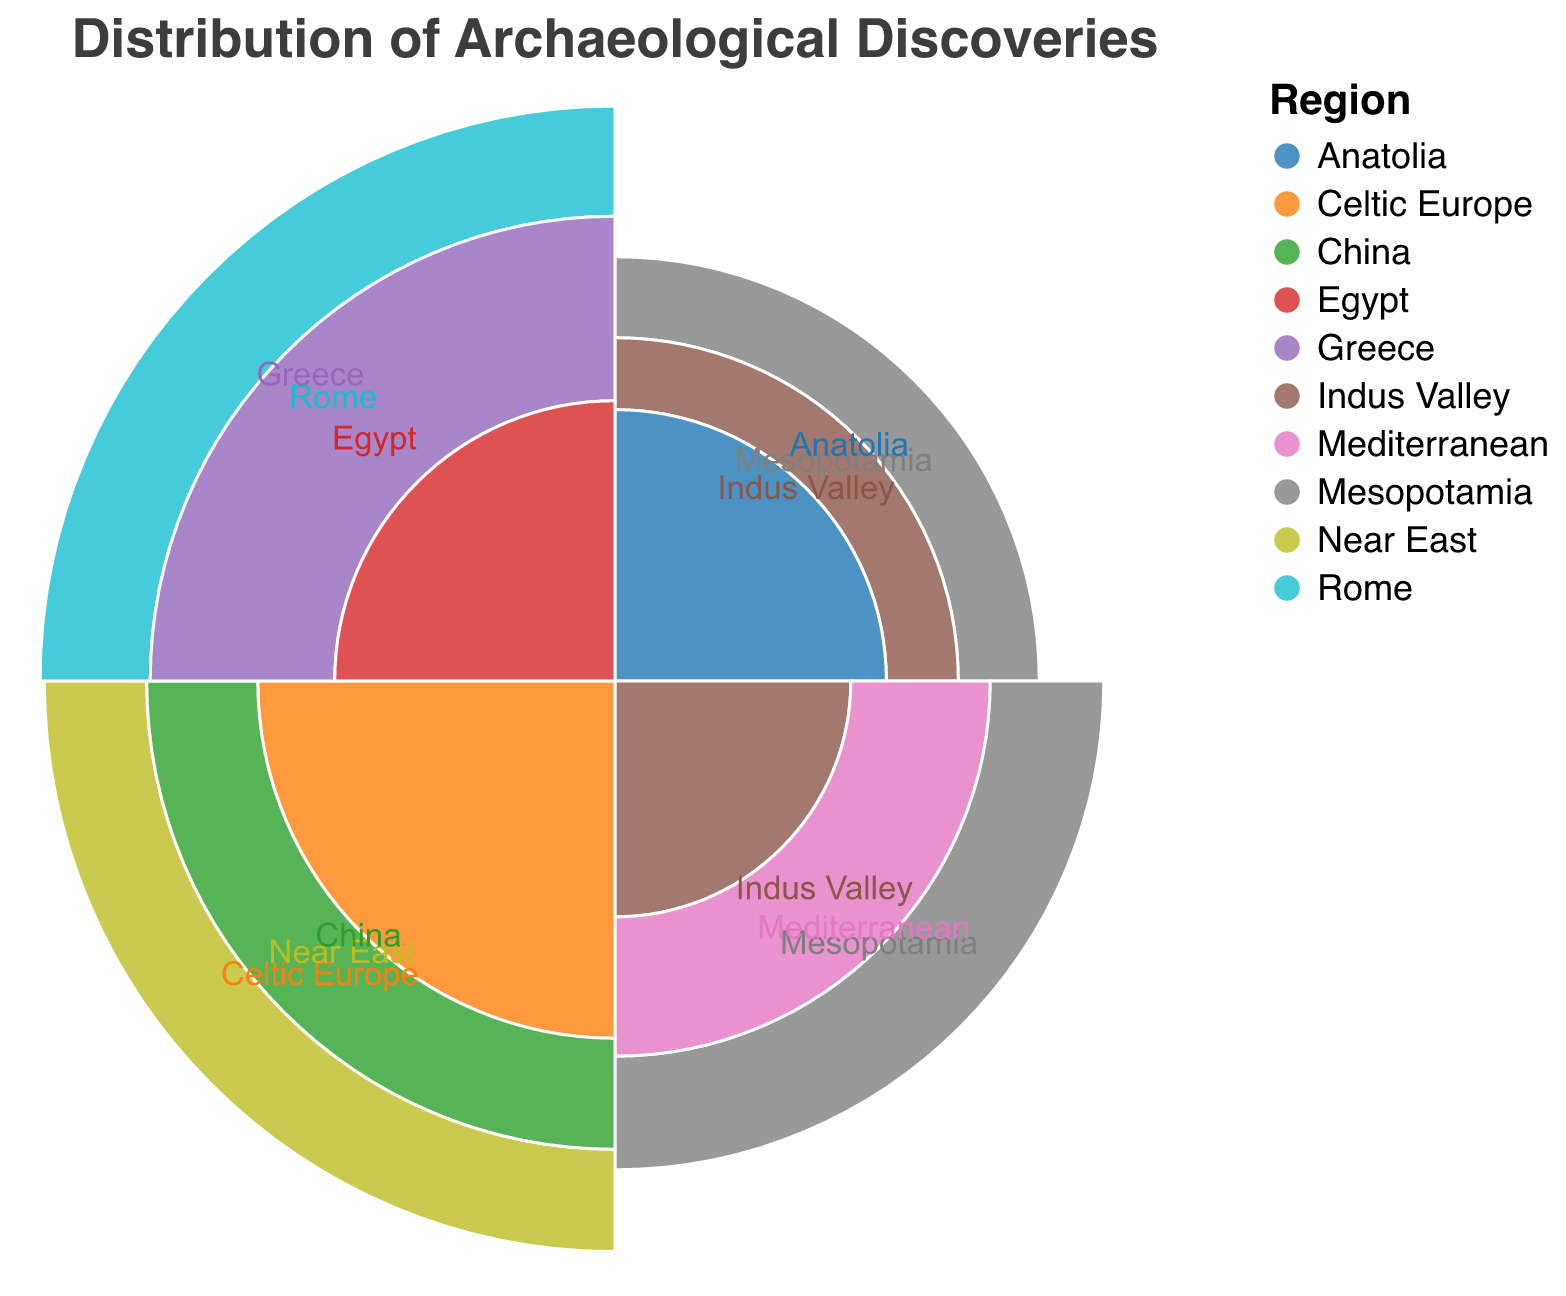What is the title of the chart? The title of the chart is displayed at the top of the figure in a prominent position.
Answer: Distribution of Archaeological Discoveries How many regions are represented in the Neolithic period? The Neolithic period includes Mesopotamia, Indus Valley, and Anatolia.
Answer: 3 Which region in the Neolithic period has the highest discovery count? By observing the discovery counts for each region in the Neolithic period, Anatolia has the highest with 45 discoveries.
Answer: Anatolia What are the regions represented in the Classical Antiquity period? Classical Antiquity period includes Rome, Greece, and Egypt.
Answer: Rome, Greece, Egypt Which historical period has the highest total number of discoveries? Sum the discoveries for each period: Neolithic (38 + 27 + 45 = 110), Bronze Age (60 + 34 + 52 = 146), Iron Age (78 + 65 + 56 = 199), Classical Antiquity (70 + 84 + 48 = 202).
Answer: Classical Antiquity Which region has the lowest number of discoveries, and in which period does it fall? By comparing all discovery counts across periods, Indus Valley in the Neolithic period has the lowest with 27 discoveries.
Answer: Indus Valley, Neolithic What is the total number of discoveries for the Iron Age period? Sum the discoveries for the Iron Age period: 78 (Celtic Europe) + 65 (Near East) + 56 (China) = 199.
Answer: 199 Which region in the Classical Antiquity period has the highest discovery count? By comparing the discovery counts for each region in the Classical Antiquity period, Greece has the highest with 84 discoveries.
Answer: Greece How does the number of discoveries in Mesopotamia during the Neolithic period compare to the Bronze Age? Compare the numbers: Mesopotamia has 38 discoveries in the Neolithic period and 60 in the Bronze Age.
Answer: Bronze Age has more What is the difference in discovery counts between the highest (Greece) and lowest (Indus Valley, Neolithic) regions? Subtract the lowest discovery count from the highest: Greece (84) - Indus Valley, Neolithic (27) = 57.
Answer: 57 